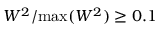<formula> <loc_0><loc_0><loc_500><loc_500>W ^ { 2 } / \max ( W ^ { 2 } ) \geq 0 . 1 \</formula> 